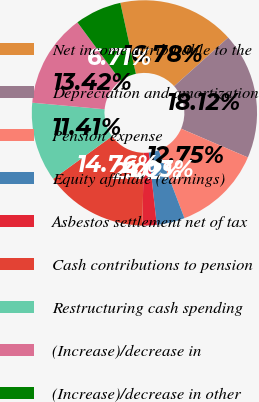<chart> <loc_0><loc_0><loc_500><loc_500><pie_chart><fcel>Net income attributable to the<fcel>Depreciation and amortization<fcel>Pension expense<fcel>Equity affiliate (earnings)<fcel>Asbestos settlement net of tax<fcel>Cash contributions to pension<fcel>Restructuring cash spending<fcel>(Increase)/decrease in<fcel>(Increase)/decrease in other<nl><fcel>16.78%<fcel>18.12%<fcel>12.75%<fcel>4.03%<fcel>2.02%<fcel>14.76%<fcel>11.41%<fcel>13.42%<fcel>6.71%<nl></chart> 